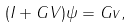Convert formula to latex. <formula><loc_0><loc_0><loc_500><loc_500>( I + G V ) \psi = G v ,</formula> 